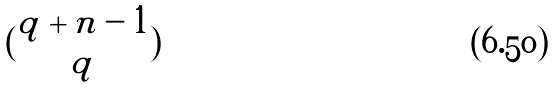Convert formula to latex. <formula><loc_0><loc_0><loc_500><loc_500>( \begin{matrix} q + n - 1 \\ q \end{matrix} )</formula> 